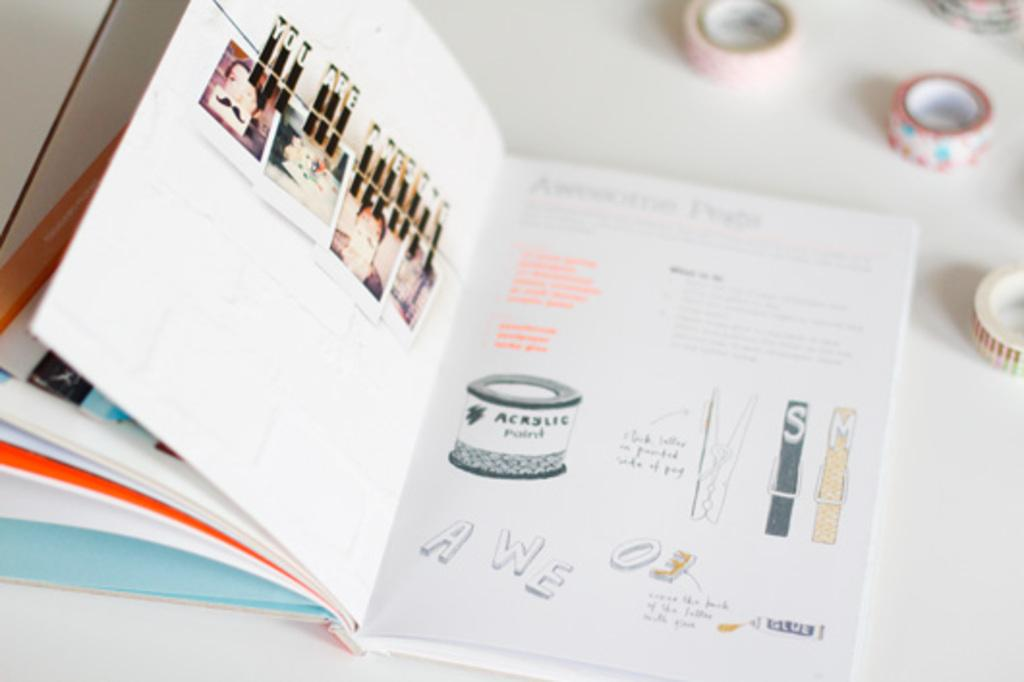<image>
Provide a brief description of the given image. A book that is opened to a page that says you are awesome. 